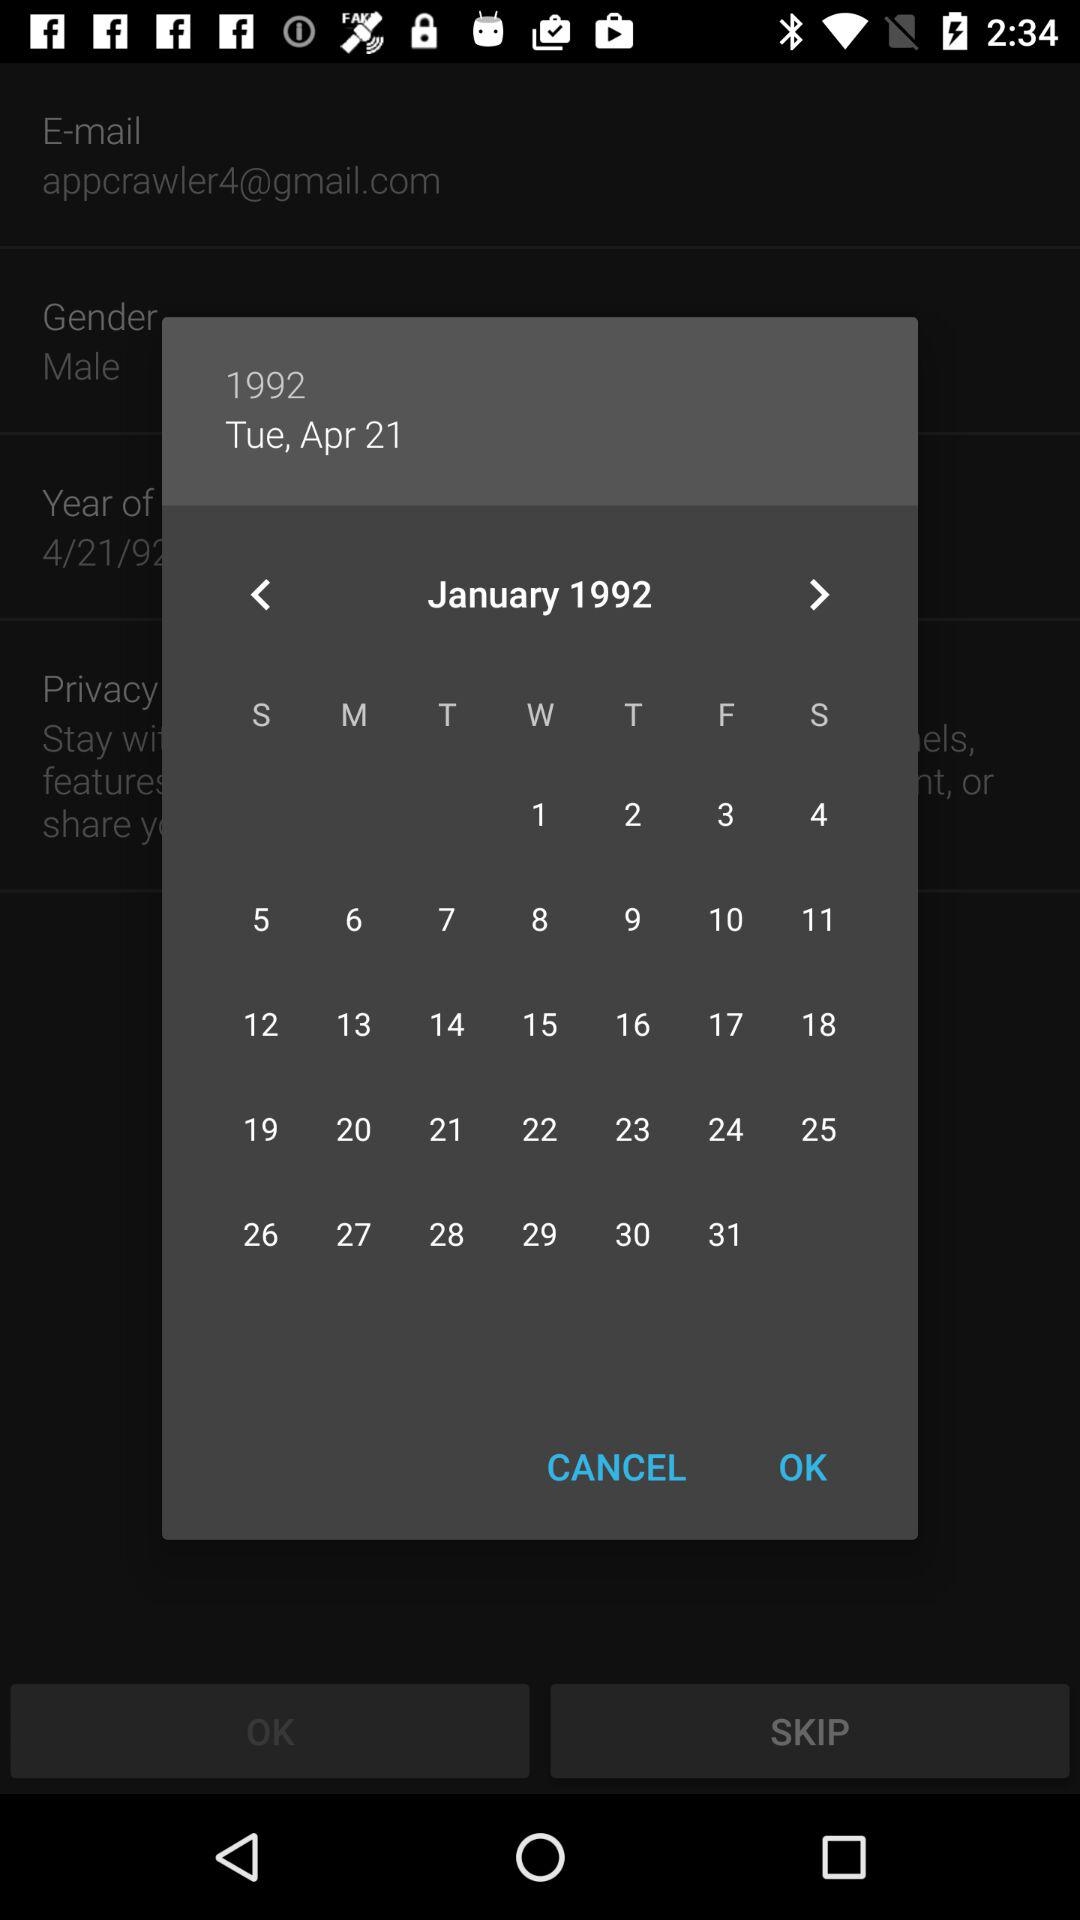What is the user's name?
When the provided information is insufficient, respond with <no answer>. <no answer> 